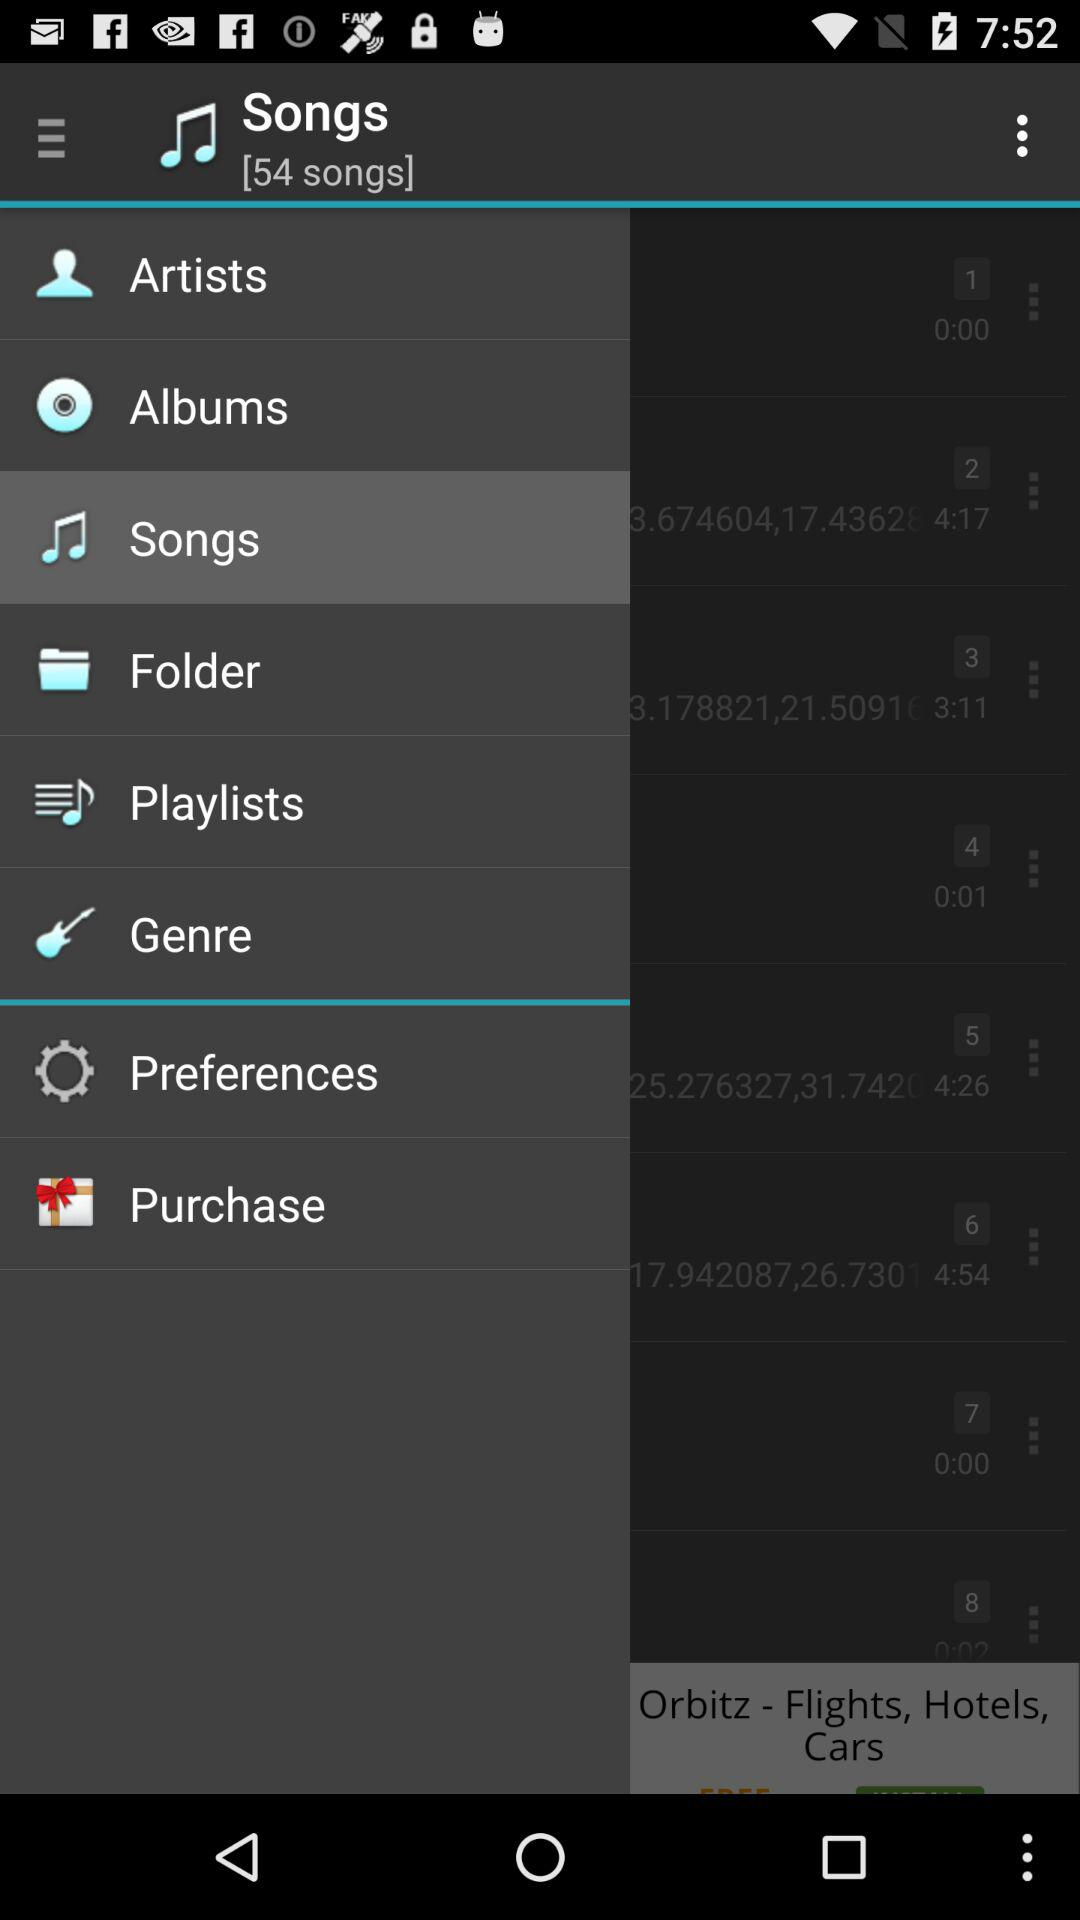What is the total number of songs in the list? The total number of songs is 54. 